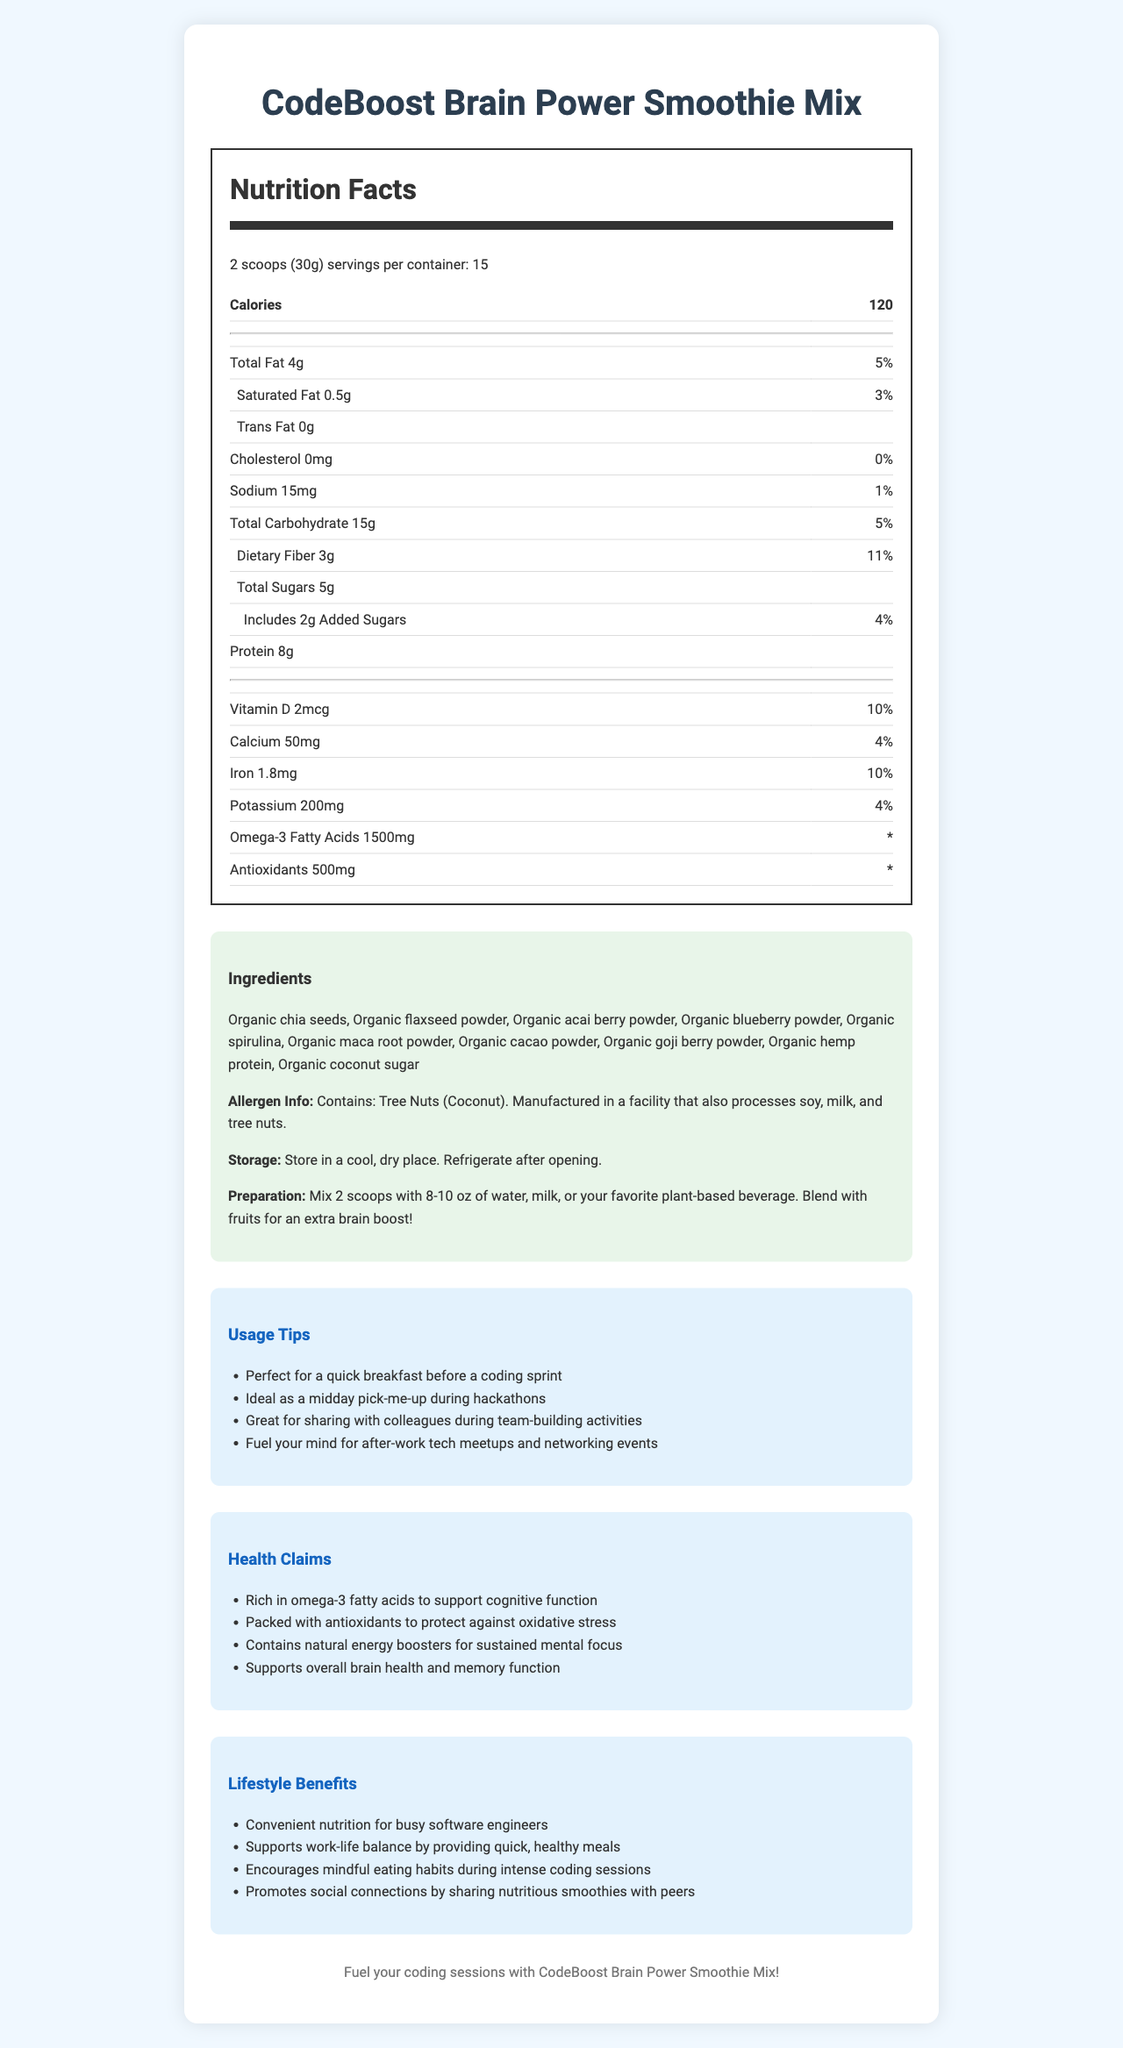what is the serving size? The serving size is mentioned at the beginning of the Nutrition Facts Label.
Answer: 2 scoops (30g) how many calories are in one serving? The calories per serving are listed directly under the serving size information.
Answer: 120 what natural ingredient provides omega-3 fatty acids in the smoothie mix? The ingredients list includes Organic chia seeds and Organic flaxseed powder, known sources of omega-3 fatty acids.
Answer: Organic chia seeds, Organic flaxseed powder what is the daily value percentage of dietary fiber per serving? The daily value percentage for dietary fiber is provided as 11% in the Nutrition Facts Label.
Answer: 11% how much protein is in one serving of the smoothie mix? The protein content per serving is listed as 8g in the Nutrition Facts Label.
Answer: 8g which of the following ingredients is NOT in the smoothie mix? A. Organic spirulina B. Organic maca root powder C. Organic matcha powder Organic matcha powder is not listed in the ingredients section, whereas Organic spirulina and Organic maca root powder are.
Answer: C. Organic matcha powder how many total sugars are in one serving of the smoothie mix? A. 2g B. 5g C. 8g D. 10g The total sugars per serving are listed as 5g in the Nutrition Facts Label.
Answer: B. 5g does the smoothie mix contain any tree nuts? The allergen information clearly states that the product contains Tree Nuts (Coconut).
Answer: Yes is there any vitamin D in the smoothie mix? There is 2mcg of Vitamin D per serving, which represents 10% of the daily value.
Answer: Yes summarize the main benefits of CodeBoost Brain Power Smoothie Mix. The explanation details the various benefits highlighted in the health claims, usage tips, and lifestyle benefits sections of the document.
Answer: The CodeBoost Brain Power Smoothie Mix is a nutritious blend designed to enhance brain function. It's rich in omega-3 fatty acids and antioxidants, supports cognitive function, and contains ingredients like chia seeds, flaxseed powder, and acai berry powder. The mix is convenient for busy individuals, helps maintain work-life balance, and promotes mindful eating habits. which plant-based beverage is recommended for blending the smoothie mix? The preparation instructions suggest mixing with "your favorite plant-based beverage" but do not specify any particular beverage.
Answer: Cannot be determined how does the smoothie mix support cognitive function? The health claims section highlights that the smoothie mix is rich in omega-3 fatty acids and antioxidants, which support cognitive function.
Answer: By being rich in omega-3 fatty acids and packed with antioxidants 